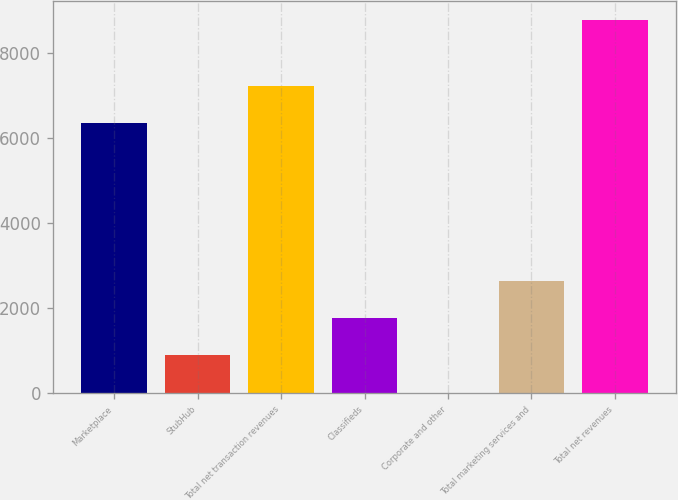<chart> <loc_0><loc_0><loc_500><loc_500><bar_chart><fcel>Marketplace<fcel>StubHub<fcel>Total net transaction revenues<fcel>Classifieds<fcel>Corporate and other<fcel>Total marketing services and<fcel>Total net revenues<nl><fcel>6351<fcel>887.1<fcel>7229.1<fcel>1765.2<fcel>9<fcel>2643.3<fcel>8790<nl></chart> 